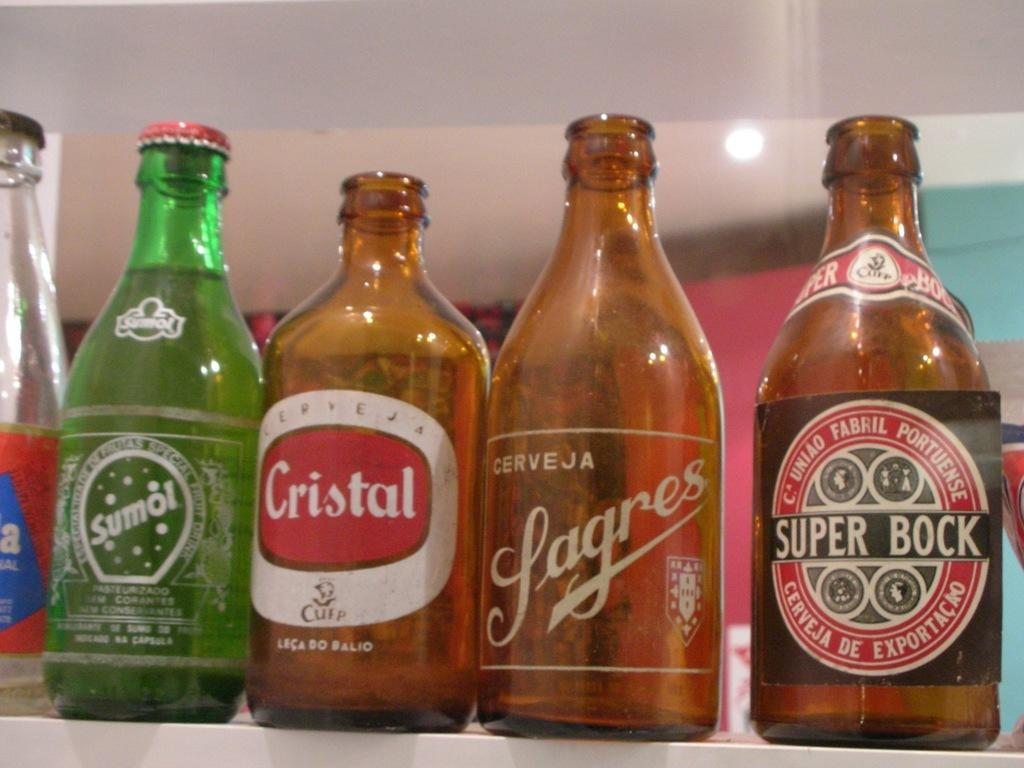<image>
Provide a brief description of the given image. Four bottles, the one of the far left being labelled Super Bock 